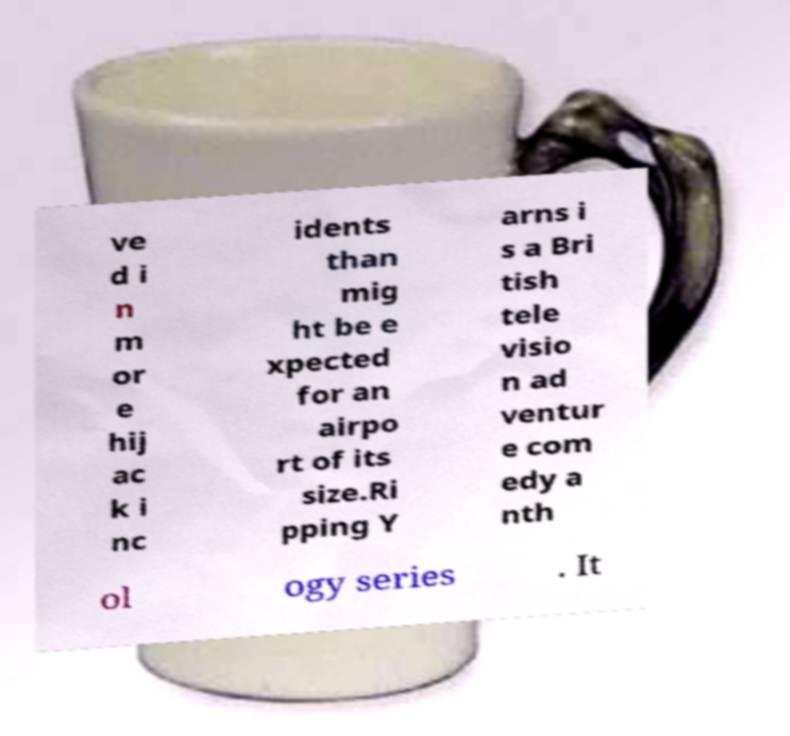Can you read and provide the text displayed in the image?This photo seems to have some interesting text. Can you extract and type it out for me? ve d i n m or e hij ac k i nc idents than mig ht be e xpected for an airpo rt of its size.Ri pping Y arns i s a Bri tish tele visio n ad ventur e com edy a nth ol ogy series . It 